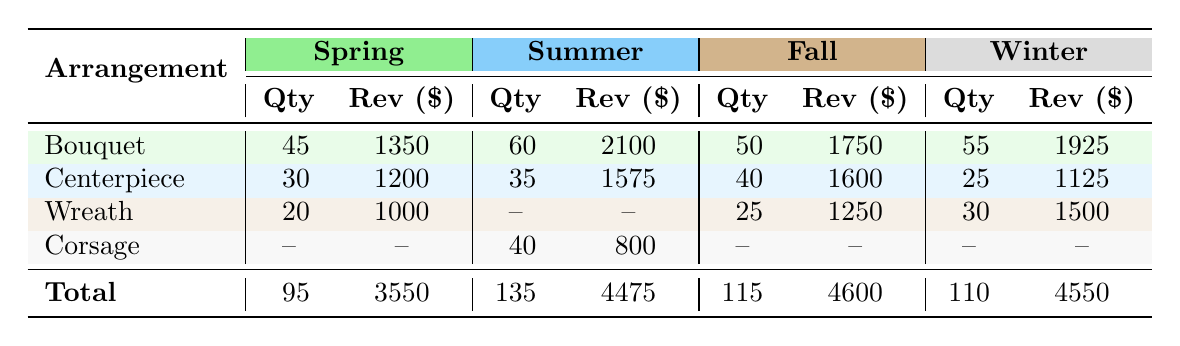What is the total quantity of Bouquets sold across all seasons? The total quantity of Bouquets can be found by adding the quantities from each season: Spring (45) + Summer (60) + Fall (50) + Winter (55) = 210.
Answer: 210 Which season had the highest revenue from Centerpieces? The revenue from Centerpieces is as follows: Spring (1200), Summer (1575), Fall (1600), and Winter (1125). The highest revenue is from Fall, at 1600.
Answer: Fall How many Corsages were sold in Summer? According to the table, Corsages are listed under Summer with a quantity of 40, indicating that 40 Corsages were sold.
Answer: 40 What is the average revenue for Wreaths sold across all seasons? The total revenue from Wreaths is: Spring (1000) + Fall (1250) + Winter (1500) = 2750. There are 3 seasons with Wreaths, so the average revenue is 2750 / 3 = 916.67.
Answer: 916.67 Did more Bouquets or Centerpieces generate higher total revenue? The total revenue for Bouquets is 1350 (Spring) + 2100 (Summer) + 1750 (Fall) + 1925 (Winter) = 8100. For Centerpieces, it is 1200 (Spring) + 1575 (Summer) + 1600 (Fall) + 1125 (Winter) = 4500. Comparatively, Bouquets generated higher total revenue than Centerpieces.
Answer: Yes What is the total revenue generated from all flower arrangements in Winter? The total revenue in Winter can be calculated by adding the total revenues of Bouquets (1925), Wreaths (1500), and Centerpieces (1125): 1925 + 1500 + 1125 = 4550.
Answer: 4550 Which arrangement type had the least quantity sold in Spring? In Spring, the arrangement types and quantities are: Bouquets (45), Centerpieces (30), and Wreaths (20). The least quantity sold is Wreaths with 20.
Answer: Wreath If we combine the quantities of all arrangement types in Summer, what is the total? The quantities of all arrangement types in Summer are: Bouquets (60), Centerpieces (35), and Corsages (40). Adding these gives: 60 + 35 + 40 = 135.
Answer: 135 